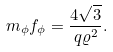<formula> <loc_0><loc_0><loc_500><loc_500>m _ { \phi } f _ { \phi } = \frac { 4 \sqrt { 3 } } { q \varrho ^ { 2 } } .</formula> 